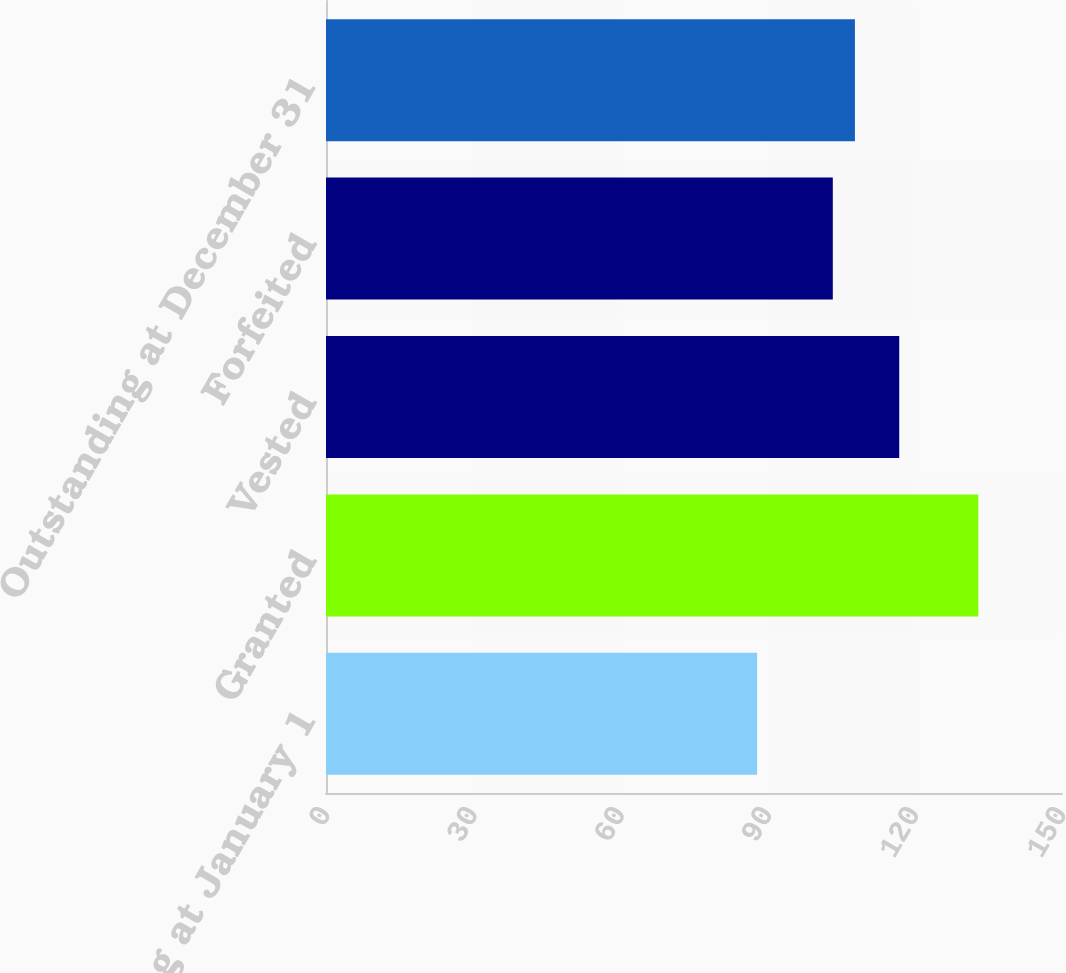<chart> <loc_0><loc_0><loc_500><loc_500><bar_chart><fcel>Outstanding at January 1<fcel>Granted<fcel>Vested<fcel>Forfeited<fcel>Outstanding at December 31<nl><fcel>87.86<fcel>132.95<fcel>116.83<fcel>103.29<fcel>107.8<nl></chart> 